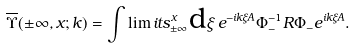<formula> <loc_0><loc_0><loc_500><loc_500>\overline { \Upsilon } ( \pm \infty , x ; k ) = \int \lim i t s _ { \pm \infty } ^ { x } \text {d} \xi \, e ^ { - i k \xi A } \Phi ^ { - 1 } _ { - } R \Phi _ { - } e ^ { i k \xi A } .</formula> 